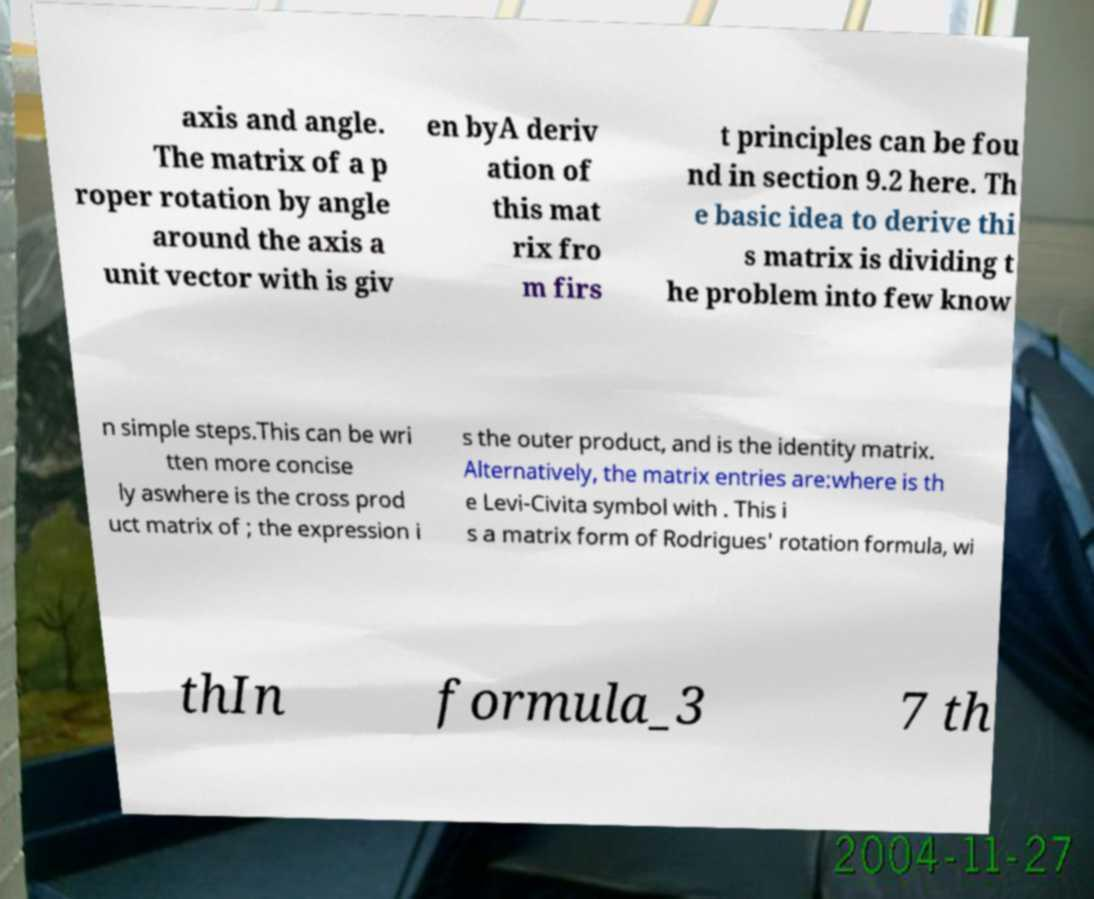For documentation purposes, I need the text within this image transcribed. Could you provide that? axis and angle. The matrix of a p roper rotation by angle around the axis a unit vector with is giv en byA deriv ation of this mat rix fro m firs t principles can be fou nd in section 9.2 here. Th e basic idea to derive thi s matrix is dividing t he problem into few know n simple steps.This can be wri tten more concise ly aswhere is the cross prod uct matrix of ; the expression i s the outer product, and is the identity matrix. Alternatively, the matrix entries are:where is th e Levi-Civita symbol with . This i s a matrix form of Rodrigues' rotation formula, wi thIn formula_3 7 th 